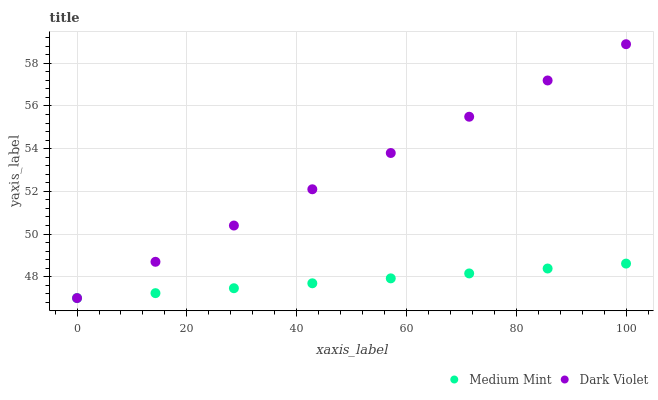Does Medium Mint have the minimum area under the curve?
Answer yes or no. Yes. Does Dark Violet have the maximum area under the curve?
Answer yes or no. Yes. Does Dark Violet have the minimum area under the curve?
Answer yes or no. No. Is Medium Mint the smoothest?
Answer yes or no. Yes. Is Dark Violet the roughest?
Answer yes or no. Yes. Is Dark Violet the smoothest?
Answer yes or no. No. Does Medium Mint have the lowest value?
Answer yes or no. Yes. Does Dark Violet have the highest value?
Answer yes or no. Yes. Does Dark Violet intersect Medium Mint?
Answer yes or no. Yes. Is Dark Violet less than Medium Mint?
Answer yes or no. No. Is Dark Violet greater than Medium Mint?
Answer yes or no. No. 